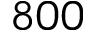<formula> <loc_0><loc_0><loc_500><loc_500>8 0 0</formula> 